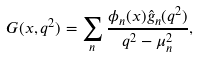<formula> <loc_0><loc_0><loc_500><loc_500>G ( x , q ^ { 2 } ) = \sum _ { n } \frac { \phi _ { n } ( x ) \hat { g } _ { n } ( q ^ { 2 } ) } { q ^ { 2 } - \mu _ { n } ^ { 2 } } ,</formula> 